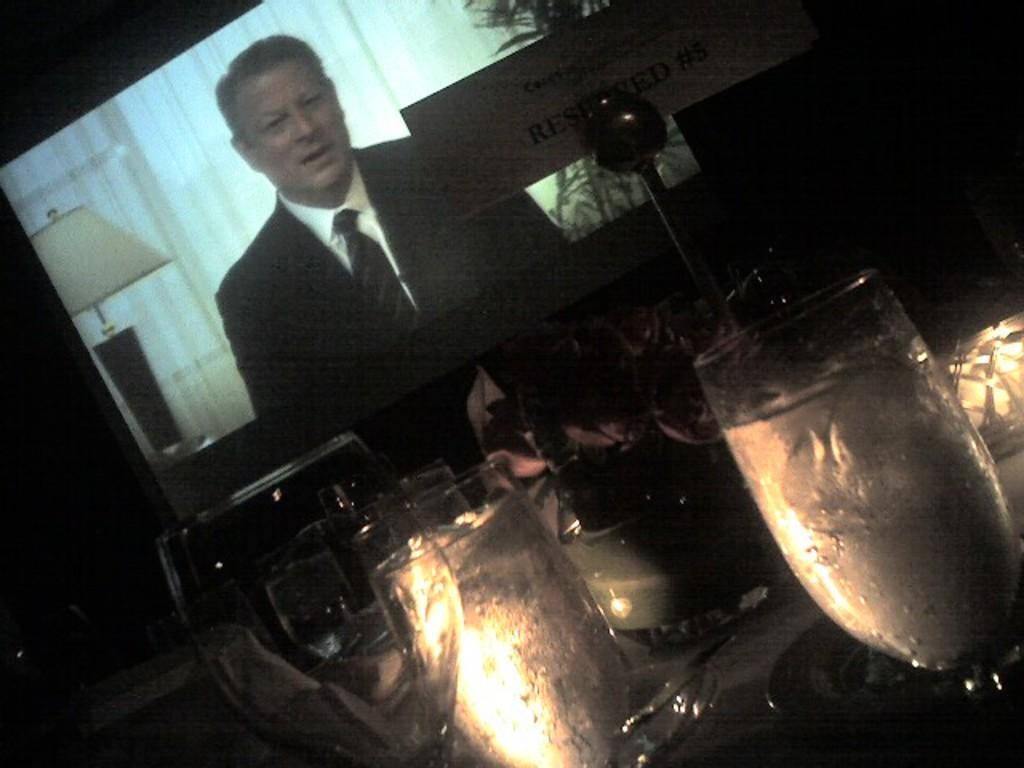What type of glasses are visible in the image? There are wine glasses in the image. Where are the wine glasses located in the image? The wine glasses are at the bottom of the image. What other object can be seen in the image besides the wine glasses? There is a board in the image. Where is the board located in the image? The board is at the top of the image. What is visible in the background of the image? There is a projector screen in the background of the image. What type of instrument is being played by the person in the image? There is no person or instrument present in the image. 